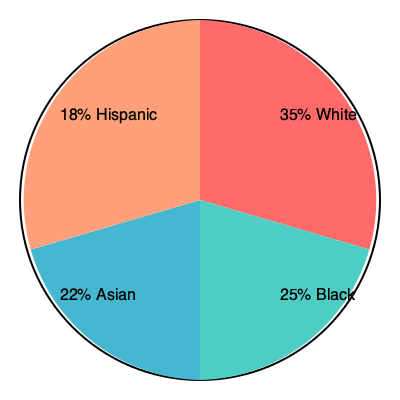As a novice writer inspired by Alice Hasters, you want to create a diverse cast of characters for your story set in a multicultural neighborhood. The pie chart represents the ethnic distribution in this fictional community. If you were to create a group of 20 main characters that accurately reflects this distribution, how many characters should be of Asian descent? To determine the number of Asian characters in a group of 20 main characters that accurately reflects the given distribution, we need to follow these steps:

1. Identify the percentage of Asian representation in the pie chart: 22%

2. Calculate the number of characters that should be Asian:
   - Total characters: 20
   - Percentage of Asian characters: 22%
   - Number of Asian characters = Total characters × Percentage
   - Number of Asian characters = $20 \times 0.22 = 4.4$

3. Since we can't have a fractional number of characters, we need to round to the nearest whole number:
   - Rounding 4.4 to the nearest whole number gives us 4

Therefore, in a group of 20 main characters that accurately reflects the ethnic distribution shown in the pie chart, 4 characters should be of Asian descent.

This approach ensures that your story's cast represents the diversity of the fictional community, aligning with the inclusive storytelling style that Alice Hasters, who writes about racism and identity, might inspire in a novice writer.
Answer: 4 characters 